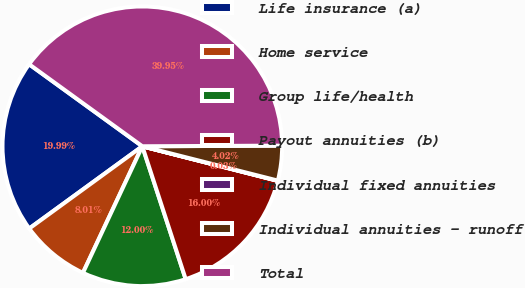Convert chart. <chart><loc_0><loc_0><loc_500><loc_500><pie_chart><fcel>Life insurance (a)<fcel>Home service<fcel>Group life/health<fcel>Payout annuities (b)<fcel>Individual fixed annuities<fcel>Individual annuities - runoff<fcel>Total<nl><fcel>19.99%<fcel>8.01%<fcel>12.0%<fcel>16.0%<fcel>0.03%<fcel>4.02%<fcel>39.95%<nl></chart> 